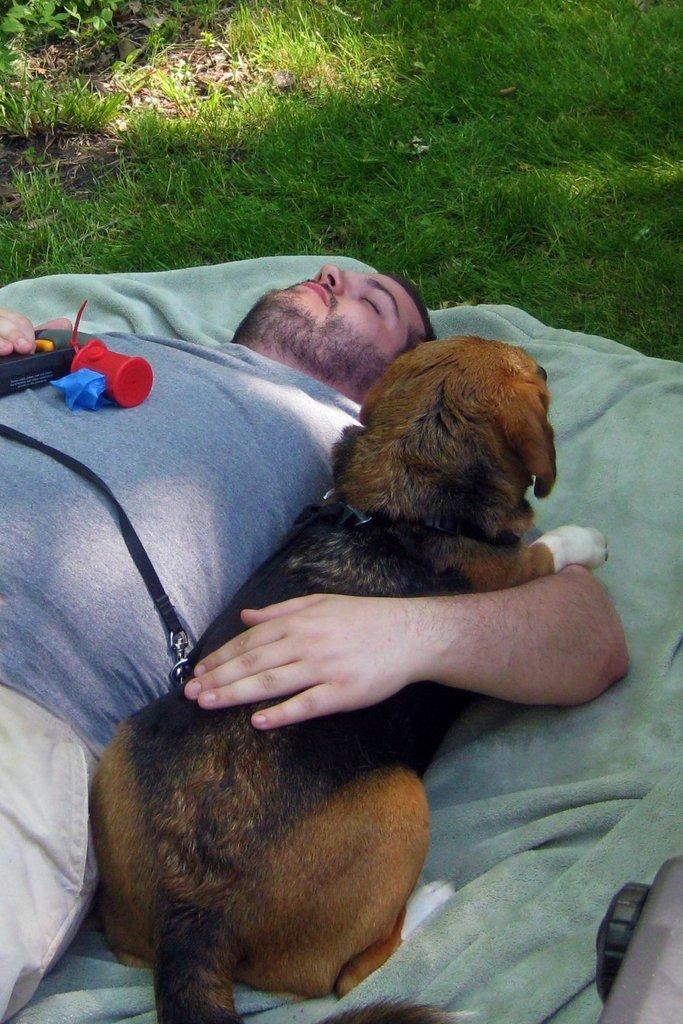What is the main subject of the image? A: The main subject of the image is a man. What is the man doing in the image? The man is sleeping in the image. What type of clothing is the man wearing? The man is wearing a t-shirt and trousers. What is the man holding in the image? The man is holding a dog in the image. What can be seen in the background of the image? There is grass and a bed sheet in the background of the image. What type of cap is the man wearing in the image? The man is not wearing a cap in the image; he is wearing a t-shirt and trousers. What type of error can be seen in the image? There is no error present in the image; it is a clear photograph of a man sleeping while holding a dog. 